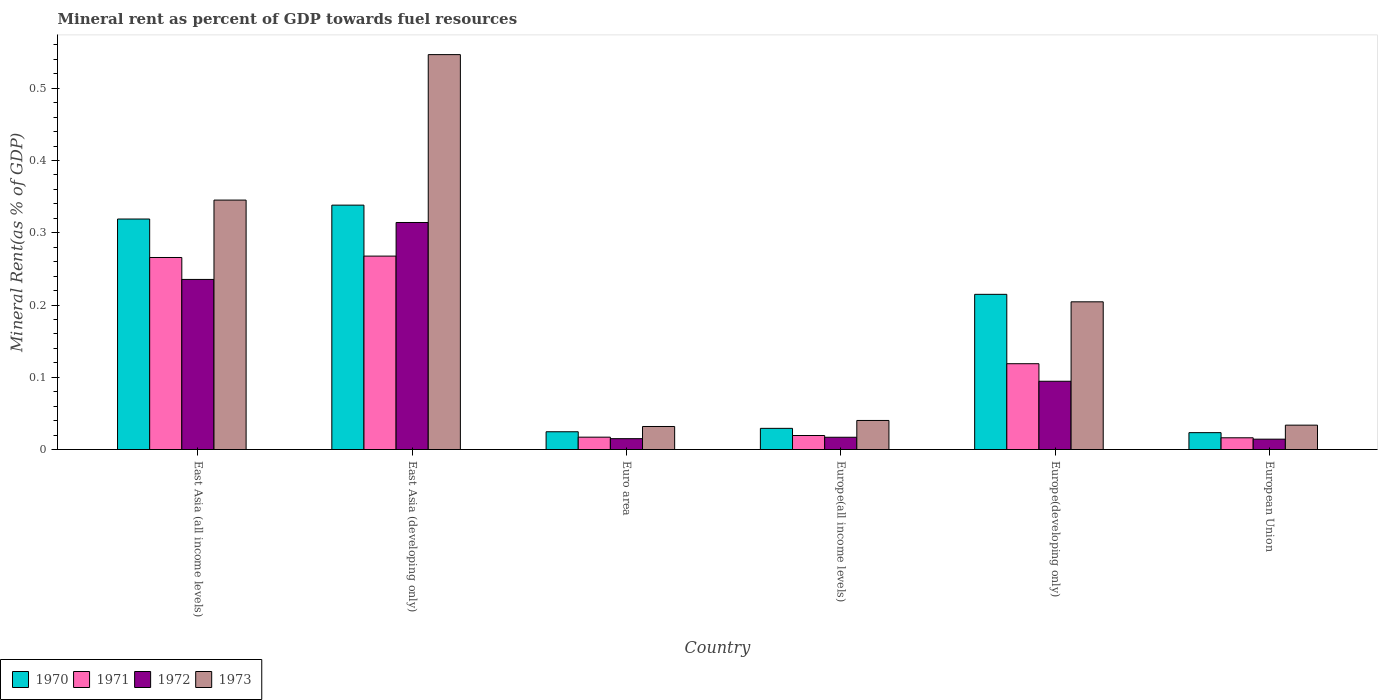How many groups of bars are there?
Give a very brief answer. 6. Are the number of bars per tick equal to the number of legend labels?
Offer a terse response. Yes. Are the number of bars on each tick of the X-axis equal?
Provide a succinct answer. Yes. How many bars are there on the 5th tick from the left?
Provide a succinct answer. 4. What is the mineral rent in 1970 in Europe(all income levels)?
Your answer should be compact. 0.03. Across all countries, what is the maximum mineral rent in 1971?
Your answer should be very brief. 0.27. Across all countries, what is the minimum mineral rent in 1970?
Provide a short and direct response. 0.02. In which country was the mineral rent in 1971 maximum?
Offer a very short reply. East Asia (developing only). In which country was the mineral rent in 1973 minimum?
Keep it short and to the point. Euro area. What is the total mineral rent in 1973 in the graph?
Make the answer very short. 1.2. What is the difference between the mineral rent in 1972 in Euro area and that in European Union?
Make the answer very short. 0. What is the difference between the mineral rent in 1971 in Europe(developing only) and the mineral rent in 1970 in European Union?
Keep it short and to the point. 0.1. What is the average mineral rent in 1971 per country?
Ensure brevity in your answer.  0.12. What is the difference between the mineral rent of/in 1972 and mineral rent of/in 1970 in East Asia (all income levels)?
Offer a terse response. -0.08. What is the ratio of the mineral rent in 1973 in East Asia (all income levels) to that in Europe(developing only)?
Offer a very short reply. 1.69. Is the mineral rent in 1973 in East Asia (all income levels) less than that in East Asia (developing only)?
Make the answer very short. Yes. Is the difference between the mineral rent in 1972 in Euro area and Europe(all income levels) greater than the difference between the mineral rent in 1970 in Euro area and Europe(all income levels)?
Your answer should be compact. Yes. What is the difference between the highest and the second highest mineral rent in 1971?
Offer a very short reply. 0.15. What is the difference between the highest and the lowest mineral rent in 1971?
Offer a very short reply. 0.25. What does the 3rd bar from the left in European Union represents?
Provide a succinct answer. 1972. What does the 1st bar from the right in European Union represents?
Keep it short and to the point. 1973. How many bars are there?
Provide a succinct answer. 24. Are all the bars in the graph horizontal?
Your response must be concise. No. What is the difference between two consecutive major ticks on the Y-axis?
Your answer should be very brief. 0.1. Are the values on the major ticks of Y-axis written in scientific E-notation?
Keep it short and to the point. No. Does the graph contain any zero values?
Give a very brief answer. No. Does the graph contain grids?
Provide a short and direct response. No. How are the legend labels stacked?
Provide a short and direct response. Horizontal. What is the title of the graph?
Make the answer very short. Mineral rent as percent of GDP towards fuel resources. What is the label or title of the Y-axis?
Give a very brief answer. Mineral Rent(as % of GDP). What is the Mineral Rent(as % of GDP) of 1970 in East Asia (all income levels)?
Provide a succinct answer. 0.32. What is the Mineral Rent(as % of GDP) in 1971 in East Asia (all income levels)?
Offer a terse response. 0.27. What is the Mineral Rent(as % of GDP) in 1972 in East Asia (all income levels)?
Your response must be concise. 0.24. What is the Mineral Rent(as % of GDP) in 1973 in East Asia (all income levels)?
Provide a short and direct response. 0.35. What is the Mineral Rent(as % of GDP) of 1970 in East Asia (developing only)?
Keep it short and to the point. 0.34. What is the Mineral Rent(as % of GDP) in 1971 in East Asia (developing only)?
Your answer should be compact. 0.27. What is the Mineral Rent(as % of GDP) in 1972 in East Asia (developing only)?
Your response must be concise. 0.31. What is the Mineral Rent(as % of GDP) of 1973 in East Asia (developing only)?
Your answer should be very brief. 0.55. What is the Mineral Rent(as % of GDP) in 1970 in Euro area?
Make the answer very short. 0.02. What is the Mineral Rent(as % of GDP) of 1971 in Euro area?
Keep it short and to the point. 0.02. What is the Mineral Rent(as % of GDP) in 1972 in Euro area?
Your answer should be compact. 0.02. What is the Mineral Rent(as % of GDP) of 1973 in Euro area?
Your answer should be compact. 0.03. What is the Mineral Rent(as % of GDP) of 1970 in Europe(all income levels)?
Ensure brevity in your answer.  0.03. What is the Mineral Rent(as % of GDP) of 1971 in Europe(all income levels)?
Your response must be concise. 0.02. What is the Mineral Rent(as % of GDP) in 1972 in Europe(all income levels)?
Your answer should be very brief. 0.02. What is the Mineral Rent(as % of GDP) in 1973 in Europe(all income levels)?
Provide a succinct answer. 0.04. What is the Mineral Rent(as % of GDP) of 1970 in Europe(developing only)?
Make the answer very short. 0.21. What is the Mineral Rent(as % of GDP) in 1971 in Europe(developing only)?
Your response must be concise. 0.12. What is the Mineral Rent(as % of GDP) of 1972 in Europe(developing only)?
Your response must be concise. 0.09. What is the Mineral Rent(as % of GDP) in 1973 in Europe(developing only)?
Offer a terse response. 0.2. What is the Mineral Rent(as % of GDP) in 1970 in European Union?
Your answer should be compact. 0.02. What is the Mineral Rent(as % of GDP) in 1971 in European Union?
Offer a very short reply. 0.02. What is the Mineral Rent(as % of GDP) of 1972 in European Union?
Provide a short and direct response. 0.01. What is the Mineral Rent(as % of GDP) of 1973 in European Union?
Offer a terse response. 0.03. Across all countries, what is the maximum Mineral Rent(as % of GDP) in 1970?
Offer a terse response. 0.34. Across all countries, what is the maximum Mineral Rent(as % of GDP) in 1971?
Your response must be concise. 0.27. Across all countries, what is the maximum Mineral Rent(as % of GDP) in 1972?
Make the answer very short. 0.31. Across all countries, what is the maximum Mineral Rent(as % of GDP) in 1973?
Your response must be concise. 0.55. Across all countries, what is the minimum Mineral Rent(as % of GDP) in 1970?
Keep it short and to the point. 0.02. Across all countries, what is the minimum Mineral Rent(as % of GDP) in 1971?
Make the answer very short. 0.02. Across all countries, what is the minimum Mineral Rent(as % of GDP) in 1972?
Provide a succinct answer. 0.01. Across all countries, what is the minimum Mineral Rent(as % of GDP) of 1973?
Ensure brevity in your answer.  0.03. What is the total Mineral Rent(as % of GDP) in 1970 in the graph?
Ensure brevity in your answer.  0.95. What is the total Mineral Rent(as % of GDP) of 1971 in the graph?
Offer a terse response. 0.7. What is the total Mineral Rent(as % of GDP) in 1972 in the graph?
Your answer should be very brief. 0.69. What is the total Mineral Rent(as % of GDP) of 1973 in the graph?
Your answer should be compact. 1.2. What is the difference between the Mineral Rent(as % of GDP) of 1970 in East Asia (all income levels) and that in East Asia (developing only)?
Provide a short and direct response. -0.02. What is the difference between the Mineral Rent(as % of GDP) of 1971 in East Asia (all income levels) and that in East Asia (developing only)?
Give a very brief answer. -0. What is the difference between the Mineral Rent(as % of GDP) of 1972 in East Asia (all income levels) and that in East Asia (developing only)?
Your answer should be compact. -0.08. What is the difference between the Mineral Rent(as % of GDP) of 1973 in East Asia (all income levels) and that in East Asia (developing only)?
Offer a terse response. -0.2. What is the difference between the Mineral Rent(as % of GDP) of 1970 in East Asia (all income levels) and that in Euro area?
Your answer should be compact. 0.29. What is the difference between the Mineral Rent(as % of GDP) in 1971 in East Asia (all income levels) and that in Euro area?
Make the answer very short. 0.25. What is the difference between the Mineral Rent(as % of GDP) in 1972 in East Asia (all income levels) and that in Euro area?
Your response must be concise. 0.22. What is the difference between the Mineral Rent(as % of GDP) in 1973 in East Asia (all income levels) and that in Euro area?
Make the answer very short. 0.31. What is the difference between the Mineral Rent(as % of GDP) in 1970 in East Asia (all income levels) and that in Europe(all income levels)?
Provide a succinct answer. 0.29. What is the difference between the Mineral Rent(as % of GDP) in 1971 in East Asia (all income levels) and that in Europe(all income levels)?
Offer a very short reply. 0.25. What is the difference between the Mineral Rent(as % of GDP) of 1972 in East Asia (all income levels) and that in Europe(all income levels)?
Ensure brevity in your answer.  0.22. What is the difference between the Mineral Rent(as % of GDP) in 1973 in East Asia (all income levels) and that in Europe(all income levels)?
Provide a short and direct response. 0.3. What is the difference between the Mineral Rent(as % of GDP) in 1970 in East Asia (all income levels) and that in Europe(developing only)?
Ensure brevity in your answer.  0.1. What is the difference between the Mineral Rent(as % of GDP) in 1971 in East Asia (all income levels) and that in Europe(developing only)?
Offer a terse response. 0.15. What is the difference between the Mineral Rent(as % of GDP) of 1972 in East Asia (all income levels) and that in Europe(developing only)?
Make the answer very short. 0.14. What is the difference between the Mineral Rent(as % of GDP) of 1973 in East Asia (all income levels) and that in Europe(developing only)?
Offer a very short reply. 0.14. What is the difference between the Mineral Rent(as % of GDP) in 1970 in East Asia (all income levels) and that in European Union?
Keep it short and to the point. 0.3. What is the difference between the Mineral Rent(as % of GDP) of 1971 in East Asia (all income levels) and that in European Union?
Make the answer very short. 0.25. What is the difference between the Mineral Rent(as % of GDP) in 1972 in East Asia (all income levels) and that in European Union?
Provide a short and direct response. 0.22. What is the difference between the Mineral Rent(as % of GDP) of 1973 in East Asia (all income levels) and that in European Union?
Provide a succinct answer. 0.31. What is the difference between the Mineral Rent(as % of GDP) of 1970 in East Asia (developing only) and that in Euro area?
Give a very brief answer. 0.31. What is the difference between the Mineral Rent(as % of GDP) in 1971 in East Asia (developing only) and that in Euro area?
Offer a terse response. 0.25. What is the difference between the Mineral Rent(as % of GDP) of 1972 in East Asia (developing only) and that in Euro area?
Your answer should be compact. 0.3. What is the difference between the Mineral Rent(as % of GDP) in 1973 in East Asia (developing only) and that in Euro area?
Make the answer very short. 0.51. What is the difference between the Mineral Rent(as % of GDP) in 1970 in East Asia (developing only) and that in Europe(all income levels)?
Make the answer very short. 0.31. What is the difference between the Mineral Rent(as % of GDP) of 1971 in East Asia (developing only) and that in Europe(all income levels)?
Offer a terse response. 0.25. What is the difference between the Mineral Rent(as % of GDP) of 1972 in East Asia (developing only) and that in Europe(all income levels)?
Provide a short and direct response. 0.3. What is the difference between the Mineral Rent(as % of GDP) in 1973 in East Asia (developing only) and that in Europe(all income levels)?
Ensure brevity in your answer.  0.51. What is the difference between the Mineral Rent(as % of GDP) of 1970 in East Asia (developing only) and that in Europe(developing only)?
Offer a terse response. 0.12. What is the difference between the Mineral Rent(as % of GDP) of 1971 in East Asia (developing only) and that in Europe(developing only)?
Your response must be concise. 0.15. What is the difference between the Mineral Rent(as % of GDP) of 1972 in East Asia (developing only) and that in Europe(developing only)?
Make the answer very short. 0.22. What is the difference between the Mineral Rent(as % of GDP) in 1973 in East Asia (developing only) and that in Europe(developing only)?
Ensure brevity in your answer.  0.34. What is the difference between the Mineral Rent(as % of GDP) of 1970 in East Asia (developing only) and that in European Union?
Provide a short and direct response. 0.31. What is the difference between the Mineral Rent(as % of GDP) of 1971 in East Asia (developing only) and that in European Union?
Keep it short and to the point. 0.25. What is the difference between the Mineral Rent(as % of GDP) of 1972 in East Asia (developing only) and that in European Union?
Ensure brevity in your answer.  0.3. What is the difference between the Mineral Rent(as % of GDP) in 1973 in East Asia (developing only) and that in European Union?
Offer a very short reply. 0.51. What is the difference between the Mineral Rent(as % of GDP) of 1970 in Euro area and that in Europe(all income levels)?
Keep it short and to the point. -0. What is the difference between the Mineral Rent(as % of GDP) of 1971 in Euro area and that in Europe(all income levels)?
Provide a short and direct response. -0. What is the difference between the Mineral Rent(as % of GDP) of 1972 in Euro area and that in Europe(all income levels)?
Your answer should be compact. -0. What is the difference between the Mineral Rent(as % of GDP) of 1973 in Euro area and that in Europe(all income levels)?
Your answer should be compact. -0.01. What is the difference between the Mineral Rent(as % of GDP) in 1970 in Euro area and that in Europe(developing only)?
Make the answer very short. -0.19. What is the difference between the Mineral Rent(as % of GDP) in 1971 in Euro area and that in Europe(developing only)?
Keep it short and to the point. -0.1. What is the difference between the Mineral Rent(as % of GDP) in 1972 in Euro area and that in Europe(developing only)?
Your answer should be compact. -0.08. What is the difference between the Mineral Rent(as % of GDP) in 1973 in Euro area and that in Europe(developing only)?
Provide a succinct answer. -0.17. What is the difference between the Mineral Rent(as % of GDP) in 1970 in Euro area and that in European Union?
Provide a short and direct response. 0. What is the difference between the Mineral Rent(as % of GDP) in 1971 in Euro area and that in European Union?
Your answer should be compact. 0. What is the difference between the Mineral Rent(as % of GDP) in 1972 in Euro area and that in European Union?
Make the answer very short. 0. What is the difference between the Mineral Rent(as % of GDP) in 1973 in Euro area and that in European Union?
Give a very brief answer. -0. What is the difference between the Mineral Rent(as % of GDP) of 1970 in Europe(all income levels) and that in Europe(developing only)?
Give a very brief answer. -0.19. What is the difference between the Mineral Rent(as % of GDP) in 1971 in Europe(all income levels) and that in Europe(developing only)?
Your response must be concise. -0.1. What is the difference between the Mineral Rent(as % of GDP) in 1972 in Europe(all income levels) and that in Europe(developing only)?
Your answer should be very brief. -0.08. What is the difference between the Mineral Rent(as % of GDP) in 1973 in Europe(all income levels) and that in Europe(developing only)?
Your answer should be very brief. -0.16. What is the difference between the Mineral Rent(as % of GDP) of 1970 in Europe(all income levels) and that in European Union?
Offer a terse response. 0.01. What is the difference between the Mineral Rent(as % of GDP) in 1971 in Europe(all income levels) and that in European Union?
Your answer should be compact. 0. What is the difference between the Mineral Rent(as % of GDP) in 1972 in Europe(all income levels) and that in European Union?
Ensure brevity in your answer.  0. What is the difference between the Mineral Rent(as % of GDP) in 1973 in Europe(all income levels) and that in European Union?
Give a very brief answer. 0.01. What is the difference between the Mineral Rent(as % of GDP) of 1970 in Europe(developing only) and that in European Union?
Your answer should be compact. 0.19. What is the difference between the Mineral Rent(as % of GDP) in 1971 in Europe(developing only) and that in European Union?
Make the answer very short. 0.1. What is the difference between the Mineral Rent(as % of GDP) in 1972 in Europe(developing only) and that in European Union?
Offer a very short reply. 0.08. What is the difference between the Mineral Rent(as % of GDP) in 1973 in Europe(developing only) and that in European Union?
Provide a succinct answer. 0.17. What is the difference between the Mineral Rent(as % of GDP) in 1970 in East Asia (all income levels) and the Mineral Rent(as % of GDP) in 1971 in East Asia (developing only)?
Your answer should be very brief. 0.05. What is the difference between the Mineral Rent(as % of GDP) in 1970 in East Asia (all income levels) and the Mineral Rent(as % of GDP) in 1972 in East Asia (developing only)?
Offer a very short reply. 0. What is the difference between the Mineral Rent(as % of GDP) in 1970 in East Asia (all income levels) and the Mineral Rent(as % of GDP) in 1973 in East Asia (developing only)?
Ensure brevity in your answer.  -0.23. What is the difference between the Mineral Rent(as % of GDP) of 1971 in East Asia (all income levels) and the Mineral Rent(as % of GDP) of 1972 in East Asia (developing only)?
Your answer should be very brief. -0.05. What is the difference between the Mineral Rent(as % of GDP) in 1971 in East Asia (all income levels) and the Mineral Rent(as % of GDP) in 1973 in East Asia (developing only)?
Your answer should be very brief. -0.28. What is the difference between the Mineral Rent(as % of GDP) in 1972 in East Asia (all income levels) and the Mineral Rent(as % of GDP) in 1973 in East Asia (developing only)?
Keep it short and to the point. -0.31. What is the difference between the Mineral Rent(as % of GDP) in 1970 in East Asia (all income levels) and the Mineral Rent(as % of GDP) in 1971 in Euro area?
Provide a short and direct response. 0.3. What is the difference between the Mineral Rent(as % of GDP) in 1970 in East Asia (all income levels) and the Mineral Rent(as % of GDP) in 1972 in Euro area?
Keep it short and to the point. 0.3. What is the difference between the Mineral Rent(as % of GDP) in 1970 in East Asia (all income levels) and the Mineral Rent(as % of GDP) in 1973 in Euro area?
Offer a very short reply. 0.29. What is the difference between the Mineral Rent(as % of GDP) in 1971 in East Asia (all income levels) and the Mineral Rent(as % of GDP) in 1972 in Euro area?
Offer a terse response. 0.25. What is the difference between the Mineral Rent(as % of GDP) in 1971 in East Asia (all income levels) and the Mineral Rent(as % of GDP) in 1973 in Euro area?
Give a very brief answer. 0.23. What is the difference between the Mineral Rent(as % of GDP) of 1972 in East Asia (all income levels) and the Mineral Rent(as % of GDP) of 1973 in Euro area?
Offer a very short reply. 0.2. What is the difference between the Mineral Rent(as % of GDP) in 1970 in East Asia (all income levels) and the Mineral Rent(as % of GDP) in 1971 in Europe(all income levels)?
Provide a short and direct response. 0.3. What is the difference between the Mineral Rent(as % of GDP) of 1970 in East Asia (all income levels) and the Mineral Rent(as % of GDP) of 1972 in Europe(all income levels)?
Your answer should be very brief. 0.3. What is the difference between the Mineral Rent(as % of GDP) of 1970 in East Asia (all income levels) and the Mineral Rent(as % of GDP) of 1973 in Europe(all income levels)?
Provide a succinct answer. 0.28. What is the difference between the Mineral Rent(as % of GDP) in 1971 in East Asia (all income levels) and the Mineral Rent(as % of GDP) in 1972 in Europe(all income levels)?
Your response must be concise. 0.25. What is the difference between the Mineral Rent(as % of GDP) in 1971 in East Asia (all income levels) and the Mineral Rent(as % of GDP) in 1973 in Europe(all income levels)?
Your answer should be compact. 0.23. What is the difference between the Mineral Rent(as % of GDP) in 1972 in East Asia (all income levels) and the Mineral Rent(as % of GDP) in 1973 in Europe(all income levels)?
Give a very brief answer. 0.2. What is the difference between the Mineral Rent(as % of GDP) in 1970 in East Asia (all income levels) and the Mineral Rent(as % of GDP) in 1971 in Europe(developing only)?
Your response must be concise. 0.2. What is the difference between the Mineral Rent(as % of GDP) in 1970 in East Asia (all income levels) and the Mineral Rent(as % of GDP) in 1972 in Europe(developing only)?
Make the answer very short. 0.22. What is the difference between the Mineral Rent(as % of GDP) of 1970 in East Asia (all income levels) and the Mineral Rent(as % of GDP) of 1973 in Europe(developing only)?
Ensure brevity in your answer.  0.11. What is the difference between the Mineral Rent(as % of GDP) in 1971 in East Asia (all income levels) and the Mineral Rent(as % of GDP) in 1972 in Europe(developing only)?
Your answer should be very brief. 0.17. What is the difference between the Mineral Rent(as % of GDP) of 1971 in East Asia (all income levels) and the Mineral Rent(as % of GDP) of 1973 in Europe(developing only)?
Your response must be concise. 0.06. What is the difference between the Mineral Rent(as % of GDP) in 1972 in East Asia (all income levels) and the Mineral Rent(as % of GDP) in 1973 in Europe(developing only)?
Provide a succinct answer. 0.03. What is the difference between the Mineral Rent(as % of GDP) in 1970 in East Asia (all income levels) and the Mineral Rent(as % of GDP) in 1971 in European Union?
Give a very brief answer. 0.3. What is the difference between the Mineral Rent(as % of GDP) of 1970 in East Asia (all income levels) and the Mineral Rent(as % of GDP) of 1972 in European Union?
Your answer should be compact. 0.3. What is the difference between the Mineral Rent(as % of GDP) of 1970 in East Asia (all income levels) and the Mineral Rent(as % of GDP) of 1973 in European Union?
Your answer should be compact. 0.29. What is the difference between the Mineral Rent(as % of GDP) in 1971 in East Asia (all income levels) and the Mineral Rent(as % of GDP) in 1972 in European Union?
Your response must be concise. 0.25. What is the difference between the Mineral Rent(as % of GDP) of 1971 in East Asia (all income levels) and the Mineral Rent(as % of GDP) of 1973 in European Union?
Keep it short and to the point. 0.23. What is the difference between the Mineral Rent(as % of GDP) of 1972 in East Asia (all income levels) and the Mineral Rent(as % of GDP) of 1973 in European Union?
Your response must be concise. 0.2. What is the difference between the Mineral Rent(as % of GDP) in 1970 in East Asia (developing only) and the Mineral Rent(as % of GDP) in 1971 in Euro area?
Make the answer very short. 0.32. What is the difference between the Mineral Rent(as % of GDP) in 1970 in East Asia (developing only) and the Mineral Rent(as % of GDP) in 1972 in Euro area?
Keep it short and to the point. 0.32. What is the difference between the Mineral Rent(as % of GDP) of 1970 in East Asia (developing only) and the Mineral Rent(as % of GDP) of 1973 in Euro area?
Offer a very short reply. 0.31. What is the difference between the Mineral Rent(as % of GDP) of 1971 in East Asia (developing only) and the Mineral Rent(as % of GDP) of 1972 in Euro area?
Your answer should be compact. 0.25. What is the difference between the Mineral Rent(as % of GDP) in 1971 in East Asia (developing only) and the Mineral Rent(as % of GDP) in 1973 in Euro area?
Your answer should be compact. 0.24. What is the difference between the Mineral Rent(as % of GDP) in 1972 in East Asia (developing only) and the Mineral Rent(as % of GDP) in 1973 in Euro area?
Your answer should be compact. 0.28. What is the difference between the Mineral Rent(as % of GDP) in 1970 in East Asia (developing only) and the Mineral Rent(as % of GDP) in 1971 in Europe(all income levels)?
Make the answer very short. 0.32. What is the difference between the Mineral Rent(as % of GDP) of 1970 in East Asia (developing only) and the Mineral Rent(as % of GDP) of 1972 in Europe(all income levels)?
Your answer should be very brief. 0.32. What is the difference between the Mineral Rent(as % of GDP) of 1970 in East Asia (developing only) and the Mineral Rent(as % of GDP) of 1973 in Europe(all income levels)?
Give a very brief answer. 0.3. What is the difference between the Mineral Rent(as % of GDP) in 1971 in East Asia (developing only) and the Mineral Rent(as % of GDP) in 1972 in Europe(all income levels)?
Provide a succinct answer. 0.25. What is the difference between the Mineral Rent(as % of GDP) in 1971 in East Asia (developing only) and the Mineral Rent(as % of GDP) in 1973 in Europe(all income levels)?
Make the answer very short. 0.23. What is the difference between the Mineral Rent(as % of GDP) of 1972 in East Asia (developing only) and the Mineral Rent(as % of GDP) of 1973 in Europe(all income levels)?
Give a very brief answer. 0.27. What is the difference between the Mineral Rent(as % of GDP) in 1970 in East Asia (developing only) and the Mineral Rent(as % of GDP) in 1971 in Europe(developing only)?
Your response must be concise. 0.22. What is the difference between the Mineral Rent(as % of GDP) of 1970 in East Asia (developing only) and the Mineral Rent(as % of GDP) of 1972 in Europe(developing only)?
Make the answer very short. 0.24. What is the difference between the Mineral Rent(as % of GDP) of 1970 in East Asia (developing only) and the Mineral Rent(as % of GDP) of 1973 in Europe(developing only)?
Give a very brief answer. 0.13. What is the difference between the Mineral Rent(as % of GDP) in 1971 in East Asia (developing only) and the Mineral Rent(as % of GDP) in 1972 in Europe(developing only)?
Provide a succinct answer. 0.17. What is the difference between the Mineral Rent(as % of GDP) in 1971 in East Asia (developing only) and the Mineral Rent(as % of GDP) in 1973 in Europe(developing only)?
Provide a short and direct response. 0.06. What is the difference between the Mineral Rent(as % of GDP) in 1972 in East Asia (developing only) and the Mineral Rent(as % of GDP) in 1973 in Europe(developing only)?
Offer a very short reply. 0.11. What is the difference between the Mineral Rent(as % of GDP) of 1970 in East Asia (developing only) and the Mineral Rent(as % of GDP) of 1971 in European Union?
Offer a terse response. 0.32. What is the difference between the Mineral Rent(as % of GDP) in 1970 in East Asia (developing only) and the Mineral Rent(as % of GDP) in 1972 in European Union?
Keep it short and to the point. 0.32. What is the difference between the Mineral Rent(as % of GDP) of 1970 in East Asia (developing only) and the Mineral Rent(as % of GDP) of 1973 in European Union?
Make the answer very short. 0.3. What is the difference between the Mineral Rent(as % of GDP) in 1971 in East Asia (developing only) and the Mineral Rent(as % of GDP) in 1972 in European Union?
Your response must be concise. 0.25. What is the difference between the Mineral Rent(as % of GDP) of 1971 in East Asia (developing only) and the Mineral Rent(as % of GDP) of 1973 in European Union?
Make the answer very short. 0.23. What is the difference between the Mineral Rent(as % of GDP) of 1972 in East Asia (developing only) and the Mineral Rent(as % of GDP) of 1973 in European Union?
Offer a very short reply. 0.28. What is the difference between the Mineral Rent(as % of GDP) in 1970 in Euro area and the Mineral Rent(as % of GDP) in 1971 in Europe(all income levels)?
Your answer should be very brief. 0.01. What is the difference between the Mineral Rent(as % of GDP) in 1970 in Euro area and the Mineral Rent(as % of GDP) in 1972 in Europe(all income levels)?
Your response must be concise. 0.01. What is the difference between the Mineral Rent(as % of GDP) of 1970 in Euro area and the Mineral Rent(as % of GDP) of 1973 in Europe(all income levels)?
Your answer should be very brief. -0.02. What is the difference between the Mineral Rent(as % of GDP) in 1971 in Euro area and the Mineral Rent(as % of GDP) in 1972 in Europe(all income levels)?
Ensure brevity in your answer.  0. What is the difference between the Mineral Rent(as % of GDP) in 1971 in Euro area and the Mineral Rent(as % of GDP) in 1973 in Europe(all income levels)?
Offer a very short reply. -0.02. What is the difference between the Mineral Rent(as % of GDP) of 1972 in Euro area and the Mineral Rent(as % of GDP) of 1973 in Europe(all income levels)?
Your answer should be very brief. -0.03. What is the difference between the Mineral Rent(as % of GDP) in 1970 in Euro area and the Mineral Rent(as % of GDP) in 1971 in Europe(developing only)?
Your answer should be compact. -0.09. What is the difference between the Mineral Rent(as % of GDP) of 1970 in Euro area and the Mineral Rent(as % of GDP) of 1972 in Europe(developing only)?
Your answer should be compact. -0.07. What is the difference between the Mineral Rent(as % of GDP) of 1970 in Euro area and the Mineral Rent(as % of GDP) of 1973 in Europe(developing only)?
Ensure brevity in your answer.  -0.18. What is the difference between the Mineral Rent(as % of GDP) in 1971 in Euro area and the Mineral Rent(as % of GDP) in 1972 in Europe(developing only)?
Provide a succinct answer. -0.08. What is the difference between the Mineral Rent(as % of GDP) of 1971 in Euro area and the Mineral Rent(as % of GDP) of 1973 in Europe(developing only)?
Provide a succinct answer. -0.19. What is the difference between the Mineral Rent(as % of GDP) in 1972 in Euro area and the Mineral Rent(as % of GDP) in 1973 in Europe(developing only)?
Your answer should be very brief. -0.19. What is the difference between the Mineral Rent(as % of GDP) of 1970 in Euro area and the Mineral Rent(as % of GDP) of 1971 in European Union?
Make the answer very short. 0.01. What is the difference between the Mineral Rent(as % of GDP) in 1970 in Euro area and the Mineral Rent(as % of GDP) in 1972 in European Union?
Give a very brief answer. 0.01. What is the difference between the Mineral Rent(as % of GDP) of 1970 in Euro area and the Mineral Rent(as % of GDP) of 1973 in European Union?
Ensure brevity in your answer.  -0.01. What is the difference between the Mineral Rent(as % of GDP) in 1971 in Euro area and the Mineral Rent(as % of GDP) in 1972 in European Union?
Offer a terse response. 0. What is the difference between the Mineral Rent(as % of GDP) in 1971 in Euro area and the Mineral Rent(as % of GDP) in 1973 in European Union?
Offer a very short reply. -0.02. What is the difference between the Mineral Rent(as % of GDP) of 1972 in Euro area and the Mineral Rent(as % of GDP) of 1973 in European Union?
Give a very brief answer. -0.02. What is the difference between the Mineral Rent(as % of GDP) of 1970 in Europe(all income levels) and the Mineral Rent(as % of GDP) of 1971 in Europe(developing only)?
Provide a succinct answer. -0.09. What is the difference between the Mineral Rent(as % of GDP) in 1970 in Europe(all income levels) and the Mineral Rent(as % of GDP) in 1972 in Europe(developing only)?
Offer a terse response. -0.07. What is the difference between the Mineral Rent(as % of GDP) of 1970 in Europe(all income levels) and the Mineral Rent(as % of GDP) of 1973 in Europe(developing only)?
Your answer should be very brief. -0.18. What is the difference between the Mineral Rent(as % of GDP) in 1971 in Europe(all income levels) and the Mineral Rent(as % of GDP) in 1972 in Europe(developing only)?
Your answer should be compact. -0.08. What is the difference between the Mineral Rent(as % of GDP) in 1971 in Europe(all income levels) and the Mineral Rent(as % of GDP) in 1973 in Europe(developing only)?
Offer a very short reply. -0.18. What is the difference between the Mineral Rent(as % of GDP) of 1972 in Europe(all income levels) and the Mineral Rent(as % of GDP) of 1973 in Europe(developing only)?
Make the answer very short. -0.19. What is the difference between the Mineral Rent(as % of GDP) in 1970 in Europe(all income levels) and the Mineral Rent(as % of GDP) in 1971 in European Union?
Provide a short and direct response. 0.01. What is the difference between the Mineral Rent(as % of GDP) in 1970 in Europe(all income levels) and the Mineral Rent(as % of GDP) in 1972 in European Union?
Keep it short and to the point. 0.01. What is the difference between the Mineral Rent(as % of GDP) in 1970 in Europe(all income levels) and the Mineral Rent(as % of GDP) in 1973 in European Union?
Give a very brief answer. -0. What is the difference between the Mineral Rent(as % of GDP) in 1971 in Europe(all income levels) and the Mineral Rent(as % of GDP) in 1972 in European Union?
Make the answer very short. 0.01. What is the difference between the Mineral Rent(as % of GDP) in 1971 in Europe(all income levels) and the Mineral Rent(as % of GDP) in 1973 in European Union?
Offer a terse response. -0.01. What is the difference between the Mineral Rent(as % of GDP) of 1972 in Europe(all income levels) and the Mineral Rent(as % of GDP) of 1973 in European Union?
Your answer should be very brief. -0.02. What is the difference between the Mineral Rent(as % of GDP) in 1970 in Europe(developing only) and the Mineral Rent(as % of GDP) in 1971 in European Union?
Your answer should be compact. 0.2. What is the difference between the Mineral Rent(as % of GDP) in 1970 in Europe(developing only) and the Mineral Rent(as % of GDP) in 1972 in European Union?
Your response must be concise. 0.2. What is the difference between the Mineral Rent(as % of GDP) of 1970 in Europe(developing only) and the Mineral Rent(as % of GDP) of 1973 in European Union?
Offer a very short reply. 0.18. What is the difference between the Mineral Rent(as % of GDP) in 1971 in Europe(developing only) and the Mineral Rent(as % of GDP) in 1972 in European Union?
Give a very brief answer. 0.1. What is the difference between the Mineral Rent(as % of GDP) in 1971 in Europe(developing only) and the Mineral Rent(as % of GDP) in 1973 in European Union?
Offer a terse response. 0.09. What is the difference between the Mineral Rent(as % of GDP) in 1972 in Europe(developing only) and the Mineral Rent(as % of GDP) in 1973 in European Union?
Offer a terse response. 0.06. What is the average Mineral Rent(as % of GDP) in 1970 per country?
Your response must be concise. 0.16. What is the average Mineral Rent(as % of GDP) of 1971 per country?
Provide a short and direct response. 0.12. What is the average Mineral Rent(as % of GDP) in 1972 per country?
Offer a terse response. 0.12. What is the average Mineral Rent(as % of GDP) in 1973 per country?
Your response must be concise. 0.2. What is the difference between the Mineral Rent(as % of GDP) of 1970 and Mineral Rent(as % of GDP) of 1971 in East Asia (all income levels)?
Make the answer very short. 0.05. What is the difference between the Mineral Rent(as % of GDP) in 1970 and Mineral Rent(as % of GDP) in 1972 in East Asia (all income levels)?
Your answer should be compact. 0.08. What is the difference between the Mineral Rent(as % of GDP) in 1970 and Mineral Rent(as % of GDP) in 1973 in East Asia (all income levels)?
Your answer should be very brief. -0.03. What is the difference between the Mineral Rent(as % of GDP) of 1971 and Mineral Rent(as % of GDP) of 1972 in East Asia (all income levels)?
Ensure brevity in your answer.  0.03. What is the difference between the Mineral Rent(as % of GDP) in 1971 and Mineral Rent(as % of GDP) in 1973 in East Asia (all income levels)?
Your answer should be compact. -0.08. What is the difference between the Mineral Rent(as % of GDP) of 1972 and Mineral Rent(as % of GDP) of 1973 in East Asia (all income levels)?
Give a very brief answer. -0.11. What is the difference between the Mineral Rent(as % of GDP) of 1970 and Mineral Rent(as % of GDP) of 1971 in East Asia (developing only)?
Make the answer very short. 0.07. What is the difference between the Mineral Rent(as % of GDP) in 1970 and Mineral Rent(as % of GDP) in 1972 in East Asia (developing only)?
Your answer should be very brief. 0.02. What is the difference between the Mineral Rent(as % of GDP) of 1970 and Mineral Rent(as % of GDP) of 1973 in East Asia (developing only)?
Your response must be concise. -0.21. What is the difference between the Mineral Rent(as % of GDP) in 1971 and Mineral Rent(as % of GDP) in 1972 in East Asia (developing only)?
Ensure brevity in your answer.  -0.05. What is the difference between the Mineral Rent(as % of GDP) in 1971 and Mineral Rent(as % of GDP) in 1973 in East Asia (developing only)?
Your answer should be very brief. -0.28. What is the difference between the Mineral Rent(as % of GDP) in 1972 and Mineral Rent(as % of GDP) in 1973 in East Asia (developing only)?
Give a very brief answer. -0.23. What is the difference between the Mineral Rent(as % of GDP) in 1970 and Mineral Rent(as % of GDP) in 1971 in Euro area?
Provide a short and direct response. 0.01. What is the difference between the Mineral Rent(as % of GDP) in 1970 and Mineral Rent(as % of GDP) in 1972 in Euro area?
Give a very brief answer. 0.01. What is the difference between the Mineral Rent(as % of GDP) in 1970 and Mineral Rent(as % of GDP) in 1973 in Euro area?
Provide a succinct answer. -0.01. What is the difference between the Mineral Rent(as % of GDP) in 1971 and Mineral Rent(as % of GDP) in 1972 in Euro area?
Your answer should be very brief. 0. What is the difference between the Mineral Rent(as % of GDP) of 1971 and Mineral Rent(as % of GDP) of 1973 in Euro area?
Your response must be concise. -0.01. What is the difference between the Mineral Rent(as % of GDP) of 1972 and Mineral Rent(as % of GDP) of 1973 in Euro area?
Keep it short and to the point. -0.02. What is the difference between the Mineral Rent(as % of GDP) of 1970 and Mineral Rent(as % of GDP) of 1971 in Europe(all income levels)?
Make the answer very short. 0.01. What is the difference between the Mineral Rent(as % of GDP) of 1970 and Mineral Rent(as % of GDP) of 1972 in Europe(all income levels)?
Provide a short and direct response. 0.01. What is the difference between the Mineral Rent(as % of GDP) in 1970 and Mineral Rent(as % of GDP) in 1973 in Europe(all income levels)?
Give a very brief answer. -0.01. What is the difference between the Mineral Rent(as % of GDP) of 1971 and Mineral Rent(as % of GDP) of 1972 in Europe(all income levels)?
Keep it short and to the point. 0. What is the difference between the Mineral Rent(as % of GDP) in 1971 and Mineral Rent(as % of GDP) in 1973 in Europe(all income levels)?
Ensure brevity in your answer.  -0.02. What is the difference between the Mineral Rent(as % of GDP) in 1972 and Mineral Rent(as % of GDP) in 1973 in Europe(all income levels)?
Offer a very short reply. -0.02. What is the difference between the Mineral Rent(as % of GDP) in 1970 and Mineral Rent(as % of GDP) in 1971 in Europe(developing only)?
Provide a short and direct response. 0.1. What is the difference between the Mineral Rent(as % of GDP) in 1970 and Mineral Rent(as % of GDP) in 1972 in Europe(developing only)?
Give a very brief answer. 0.12. What is the difference between the Mineral Rent(as % of GDP) of 1970 and Mineral Rent(as % of GDP) of 1973 in Europe(developing only)?
Your answer should be very brief. 0.01. What is the difference between the Mineral Rent(as % of GDP) of 1971 and Mineral Rent(as % of GDP) of 1972 in Europe(developing only)?
Offer a very short reply. 0.02. What is the difference between the Mineral Rent(as % of GDP) in 1971 and Mineral Rent(as % of GDP) in 1973 in Europe(developing only)?
Your answer should be very brief. -0.09. What is the difference between the Mineral Rent(as % of GDP) in 1972 and Mineral Rent(as % of GDP) in 1973 in Europe(developing only)?
Offer a terse response. -0.11. What is the difference between the Mineral Rent(as % of GDP) of 1970 and Mineral Rent(as % of GDP) of 1971 in European Union?
Provide a succinct answer. 0.01. What is the difference between the Mineral Rent(as % of GDP) of 1970 and Mineral Rent(as % of GDP) of 1972 in European Union?
Make the answer very short. 0.01. What is the difference between the Mineral Rent(as % of GDP) in 1970 and Mineral Rent(as % of GDP) in 1973 in European Union?
Your answer should be very brief. -0.01. What is the difference between the Mineral Rent(as % of GDP) in 1971 and Mineral Rent(as % of GDP) in 1972 in European Union?
Provide a succinct answer. 0. What is the difference between the Mineral Rent(as % of GDP) in 1971 and Mineral Rent(as % of GDP) in 1973 in European Union?
Give a very brief answer. -0.02. What is the difference between the Mineral Rent(as % of GDP) of 1972 and Mineral Rent(as % of GDP) of 1973 in European Union?
Ensure brevity in your answer.  -0.02. What is the ratio of the Mineral Rent(as % of GDP) of 1970 in East Asia (all income levels) to that in East Asia (developing only)?
Your answer should be compact. 0.94. What is the ratio of the Mineral Rent(as % of GDP) in 1971 in East Asia (all income levels) to that in East Asia (developing only)?
Offer a very short reply. 0.99. What is the ratio of the Mineral Rent(as % of GDP) of 1972 in East Asia (all income levels) to that in East Asia (developing only)?
Provide a short and direct response. 0.75. What is the ratio of the Mineral Rent(as % of GDP) in 1973 in East Asia (all income levels) to that in East Asia (developing only)?
Provide a short and direct response. 0.63. What is the ratio of the Mineral Rent(as % of GDP) of 1970 in East Asia (all income levels) to that in Euro area?
Your response must be concise. 12.98. What is the ratio of the Mineral Rent(as % of GDP) of 1971 in East Asia (all income levels) to that in Euro area?
Offer a very short reply. 15.54. What is the ratio of the Mineral Rent(as % of GDP) of 1972 in East Asia (all income levels) to that in Euro area?
Offer a terse response. 15.66. What is the ratio of the Mineral Rent(as % of GDP) of 1973 in East Asia (all income levels) to that in Euro area?
Give a very brief answer. 10.83. What is the ratio of the Mineral Rent(as % of GDP) in 1970 in East Asia (all income levels) to that in Europe(all income levels)?
Provide a short and direct response. 10.89. What is the ratio of the Mineral Rent(as % of GDP) in 1971 in East Asia (all income levels) to that in Europe(all income levels)?
Your answer should be compact. 13.7. What is the ratio of the Mineral Rent(as % of GDP) of 1972 in East Asia (all income levels) to that in Europe(all income levels)?
Offer a very short reply. 13.88. What is the ratio of the Mineral Rent(as % of GDP) of 1973 in East Asia (all income levels) to that in Europe(all income levels)?
Ensure brevity in your answer.  8.58. What is the ratio of the Mineral Rent(as % of GDP) in 1970 in East Asia (all income levels) to that in Europe(developing only)?
Give a very brief answer. 1.49. What is the ratio of the Mineral Rent(as % of GDP) in 1971 in East Asia (all income levels) to that in Europe(developing only)?
Your answer should be very brief. 2.24. What is the ratio of the Mineral Rent(as % of GDP) in 1972 in East Asia (all income levels) to that in Europe(developing only)?
Your answer should be compact. 2.49. What is the ratio of the Mineral Rent(as % of GDP) of 1973 in East Asia (all income levels) to that in Europe(developing only)?
Your answer should be compact. 1.69. What is the ratio of the Mineral Rent(as % of GDP) of 1970 in East Asia (all income levels) to that in European Union?
Offer a terse response. 13.66. What is the ratio of the Mineral Rent(as % of GDP) in 1971 in East Asia (all income levels) to that in European Union?
Provide a short and direct response. 16.36. What is the ratio of the Mineral Rent(as % of GDP) of 1972 in East Asia (all income levels) to that in European Union?
Keep it short and to the point. 16.42. What is the ratio of the Mineral Rent(as % of GDP) of 1973 in East Asia (all income levels) to that in European Union?
Your answer should be very brief. 10.24. What is the ratio of the Mineral Rent(as % of GDP) in 1970 in East Asia (developing only) to that in Euro area?
Give a very brief answer. 13.76. What is the ratio of the Mineral Rent(as % of GDP) of 1971 in East Asia (developing only) to that in Euro area?
Ensure brevity in your answer.  15.65. What is the ratio of the Mineral Rent(as % of GDP) in 1972 in East Asia (developing only) to that in Euro area?
Your answer should be very brief. 20.91. What is the ratio of the Mineral Rent(as % of GDP) of 1973 in East Asia (developing only) to that in Euro area?
Offer a very short reply. 17.14. What is the ratio of the Mineral Rent(as % of GDP) in 1970 in East Asia (developing only) to that in Europe(all income levels)?
Provide a succinct answer. 11.55. What is the ratio of the Mineral Rent(as % of GDP) in 1971 in East Asia (developing only) to that in Europe(all income levels)?
Your answer should be compact. 13.8. What is the ratio of the Mineral Rent(as % of GDP) of 1972 in East Asia (developing only) to that in Europe(all income levels)?
Ensure brevity in your answer.  18.52. What is the ratio of the Mineral Rent(as % of GDP) in 1973 in East Asia (developing only) to that in Europe(all income levels)?
Ensure brevity in your answer.  13.59. What is the ratio of the Mineral Rent(as % of GDP) of 1970 in East Asia (developing only) to that in Europe(developing only)?
Ensure brevity in your answer.  1.57. What is the ratio of the Mineral Rent(as % of GDP) in 1971 in East Asia (developing only) to that in Europe(developing only)?
Your response must be concise. 2.25. What is the ratio of the Mineral Rent(as % of GDP) of 1972 in East Asia (developing only) to that in Europe(developing only)?
Provide a short and direct response. 3.33. What is the ratio of the Mineral Rent(as % of GDP) in 1973 in East Asia (developing only) to that in Europe(developing only)?
Provide a short and direct response. 2.67. What is the ratio of the Mineral Rent(as % of GDP) of 1970 in East Asia (developing only) to that in European Union?
Ensure brevity in your answer.  14.48. What is the ratio of the Mineral Rent(as % of GDP) of 1971 in East Asia (developing only) to that in European Union?
Keep it short and to the point. 16.48. What is the ratio of the Mineral Rent(as % of GDP) in 1972 in East Asia (developing only) to that in European Union?
Provide a short and direct response. 21.92. What is the ratio of the Mineral Rent(as % of GDP) of 1973 in East Asia (developing only) to that in European Union?
Offer a terse response. 16.21. What is the ratio of the Mineral Rent(as % of GDP) in 1970 in Euro area to that in Europe(all income levels)?
Offer a very short reply. 0.84. What is the ratio of the Mineral Rent(as % of GDP) of 1971 in Euro area to that in Europe(all income levels)?
Give a very brief answer. 0.88. What is the ratio of the Mineral Rent(as % of GDP) in 1972 in Euro area to that in Europe(all income levels)?
Keep it short and to the point. 0.89. What is the ratio of the Mineral Rent(as % of GDP) of 1973 in Euro area to that in Europe(all income levels)?
Offer a terse response. 0.79. What is the ratio of the Mineral Rent(as % of GDP) of 1970 in Euro area to that in Europe(developing only)?
Offer a terse response. 0.11. What is the ratio of the Mineral Rent(as % of GDP) of 1971 in Euro area to that in Europe(developing only)?
Provide a short and direct response. 0.14. What is the ratio of the Mineral Rent(as % of GDP) in 1972 in Euro area to that in Europe(developing only)?
Your answer should be very brief. 0.16. What is the ratio of the Mineral Rent(as % of GDP) of 1973 in Euro area to that in Europe(developing only)?
Provide a short and direct response. 0.16. What is the ratio of the Mineral Rent(as % of GDP) in 1970 in Euro area to that in European Union?
Provide a short and direct response. 1.05. What is the ratio of the Mineral Rent(as % of GDP) in 1971 in Euro area to that in European Union?
Offer a terse response. 1.05. What is the ratio of the Mineral Rent(as % of GDP) of 1972 in Euro area to that in European Union?
Ensure brevity in your answer.  1.05. What is the ratio of the Mineral Rent(as % of GDP) of 1973 in Euro area to that in European Union?
Your answer should be very brief. 0.95. What is the ratio of the Mineral Rent(as % of GDP) in 1970 in Europe(all income levels) to that in Europe(developing only)?
Keep it short and to the point. 0.14. What is the ratio of the Mineral Rent(as % of GDP) of 1971 in Europe(all income levels) to that in Europe(developing only)?
Make the answer very short. 0.16. What is the ratio of the Mineral Rent(as % of GDP) of 1972 in Europe(all income levels) to that in Europe(developing only)?
Offer a very short reply. 0.18. What is the ratio of the Mineral Rent(as % of GDP) in 1973 in Europe(all income levels) to that in Europe(developing only)?
Provide a short and direct response. 0.2. What is the ratio of the Mineral Rent(as % of GDP) of 1970 in Europe(all income levels) to that in European Union?
Your answer should be compact. 1.25. What is the ratio of the Mineral Rent(as % of GDP) in 1971 in Europe(all income levels) to that in European Union?
Your answer should be very brief. 1.19. What is the ratio of the Mineral Rent(as % of GDP) of 1972 in Europe(all income levels) to that in European Union?
Keep it short and to the point. 1.18. What is the ratio of the Mineral Rent(as % of GDP) of 1973 in Europe(all income levels) to that in European Union?
Offer a very short reply. 1.19. What is the ratio of the Mineral Rent(as % of GDP) in 1970 in Europe(developing only) to that in European Union?
Your response must be concise. 9.2. What is the ratio of the Mineral Rent(as % of GDP) of 1971 in Europe(developing only) to that in European Union?
Ensure brevity in your answer.  7.31. What is the ratio of the Mineral Rent(as % of GDP) in 1972 in Europe(developing only) to that in European Union?
Your answer should be compact. 6.59. What is the ratio of the Mineral Rent(as % of GDP) of 1973 in Europe(developing only) to that in European Union?
Keep it short and to the point. 6.06. What is the difference between the highest and the second highest Mineral Rent(as % of GDP) in 1970?
Provide a short and direct response. 0.02. What is the difference between the highest and the second highest Mineral Rent(as % of GDP) in 1971?
Give a very brief answer. 0. What is the difference between the highest and the second highest Mineral Rent(as % of GDP) in 1972?
Keep it short and to the point. 0.08. What is the difference between the highest and the second highest Mineral Rent(as % of GDP) of 1973?
Ensure brevity in your answer.  0.2. What is the difference between the highest and the lowest Mineral Rent(as % of GDP) in 1970?
Give a very brief answer. 0.31. What is the difference between the highest and the lowest Mineral Rent(as % of GDP) of 1971?
Give a very brief answer. 0.25. What is the difference between the highest and the lowest Mineral Rent(as % of GDP) of 1972?
Keep it short and to the point. 0.3. What is the difference between the highest and the lowest Mineral Rent(as % of GDP) in 1973?
Ensure brevity in your answer.  0.51. 